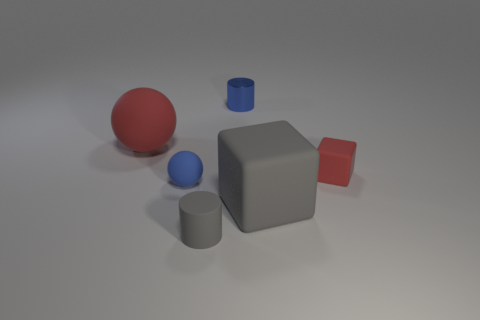The shiny thing that is the same color as the small sphere is what shape?
Provide a short and direct response. Cylinder. How many matte objects are both right of the tiny matte sphere and left of the blue metallic cylinder?
Make the answer very short. 1. Are there fewer big balls that are to the right of the red rubber block than gray rubber cylinders?
Your response must be concise. Yes. Is there a red sphere that has the same size as the metallic cylinder?
Make the answer very short. No. There is a small cylinder that is the same material as the large red object; what is its color?
Your answer should be very brief. Gray. What number of big rubber things are behind the cube behind the blue sphere?
Offer a very short reply. 1. There is a object that is both in front of the blue matte object and behind the gray matte cylinder; what material is it?
Give a very brief answer. Rubber. Do the tiny rubber thing on the left side of the gray matte cylinder and the big red object have the same shape?
Provide a succinct answer. Yes. Is the number of yellow cylinders less than the number of rubber spheres?
Ensure brevity in your answer.  Yes. What number of cubes have the same color as the tiny ball?
Keep it short and to the point. 0. 